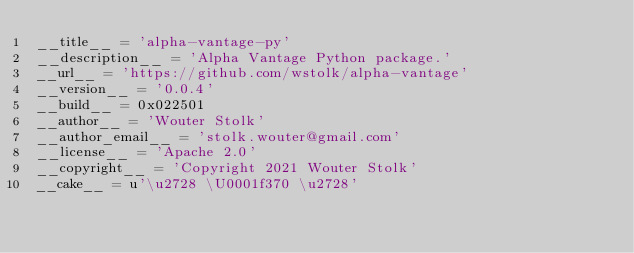Convert code to text. <code><loc_0><loc_0><loc_500><loc_500><_Python_>__title__ = 'alpha-vantage-py'
__description__ = 'Alpha Vantage Python package.'
__url__ = 'https://github.com/wstolk/alpha-vantage'
__version__ = '0.0.4'
__build__ = 0x022501
__author__ = 'Wouter Stolk'
__author_email__ = 'stolk.wouter@gmail.com'
__license__ = 'Apache 2.0'
__copyright__ = 'Copyright 2021 Wouter Stolk'
__cake__ = u'\u2728 \U0001f370 \u2728'</code> 